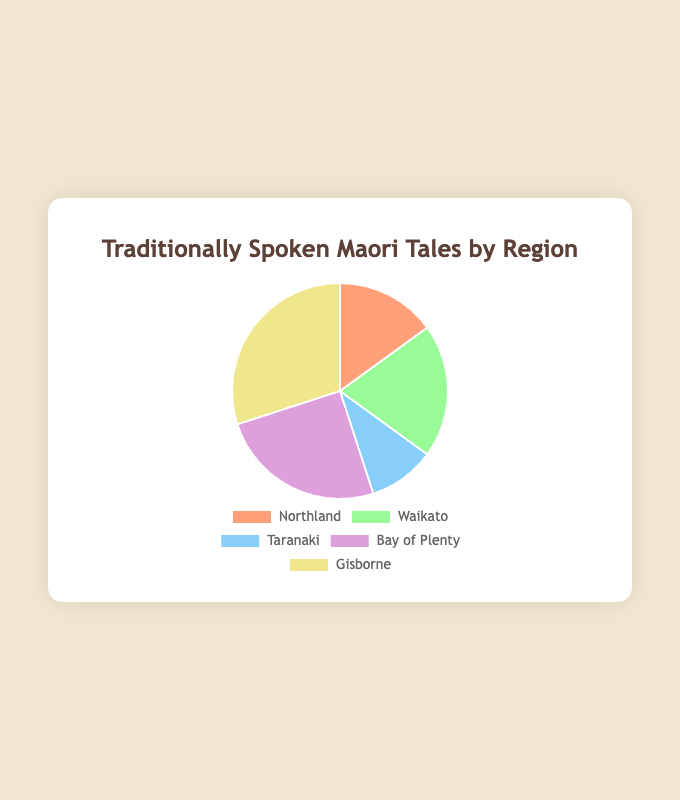Which region has the most traditionally spoken Maori tales? The region with the highest number of tales is Gisborne with 30 tales. Just look for the label with the largest segment in the pie chart.
Answer: Gisborne Which region has the fewest traditionally spoken Maori tales? The region with the smallest number of tales is Taranaki with 10 tales. This is the smallest segment in the pie chart.
Answer: Taranaki How many more tales are spoken in Bay of Plenty compared to Northland? Bay of Plenty has 25 tales, and Northland has 15 tales. The difference is 25 - 15 = 10 tales.
Answer: 10 What is the sum of tales spoken in Northland and Waikato? Northland has 15 tales and Waikato has 20 tales. The sum is 15 + 20 = 35 tales.
Answer: 35 Which two regions have an equal number of tales, when added together, equal the number of tales in Gisborne? Northland has 15 tales and Bay of Plenty has 25 tales. Adding them together, 15 + 25 equals 40, which is not equal to Gisborne's tales (which have 30 tales). So, the needed regions are none.
Answer: None What proportion of the total tales are from Waikato? The total number of tales is 15 (Northland) + 20 (Waikato) + 10 (Taranaki) + 25 (Bay of Plenty) + 30 (Gisborne) = 100 tales. Waikato's tales are 20 out of 100. Therefore, the proportion is 20/100 = 0.2 or 20%.
Answer: 20% Compare the number of tales between Waikato and Taranaki. Which is greater? Waikato has 20 tales, and Taranaki has 10 tales. Therefore, Waikato has more tales than Taranaki.
Answer: Waikato Are there more tales in Bay of Plenty, Waikato, and Taranaki combined than in Gisborne? The sum of tales for Bay of Plenty (25), Waikato (20), and Taranaki (10) is 25 + 20 + 10 = 55 tales. Gisborne has 30 tales. 55 tales are more than 30, so yes, there are more tales in Bay of Plenty, Waikato, and Taranaki combined than in Gisborne.
Answer: Yes What is the average number of tales per region? There are 5 regions with a total of 100 tales (15 Northland + 20 Waikato + 10 Taranaki + 25 Bay of Plenty + 30 Gisborne). The average number of tales per region is 100/5 = 20 tales.
Answer: 20 